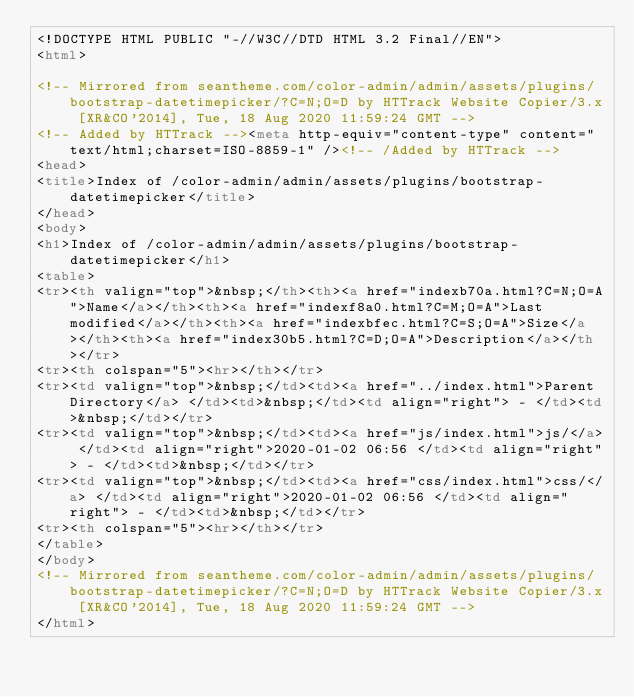<code> <loc_0><loc_0><loc_500><loc_500><_HTML_><!DOCTYPE HTML PUBLIC "-//W3C//DTD HTML 3.2 Final//EN">
<html>

<!-- Mirrored from seantheme.com/color-admin/admin/assets/plugins/bootstrap-datetimepicker/?C=N;O=D by HTTrack Website Copier/3.x [XR&CO'2014], Tue, 18 Aug 2020 11:59:24 GMT -->
<!-- Added by HTTrack --><meta http-equiv="content-type" content="text/html;charset=ISO-8859-1" /><!-- /Added by HTTrack -->
<head>
<title>Index of /color-admin/admin/assets/plugins/bootstrap-datetimepicker</title>
</head>
<body>
<h1>Index of /color-admin/admin/assets/plugins/bootstrap-datetimepicker</h1>
<table>
<tr><th valign="top">&nbsp;</th><th><a href="indexb70a.html?C=N;O=A">Name</a></th><th><a href="indexf8a0.html?C=M;O=A">Last modified</a></th><th><a href="indexbfec.html?C=S;O=A">Size</a></th><th><a href="index30b5.html?C=D;O=A">Description</a></th></tr>
<tr><th colspan="5"><hr></th></tr>
<tr><td valign="top">&nbsp;</td><td><a href="../index.html">Parent Directory</a> </td><td>&nbsp;</td><td align="right"> - </td><td>&nbsp;</td></tr>
<tr><td valign="top">&nbsp;</td><td><a href="js/index.html">js/</a> </td><td align="right">2020-01-02 06:56 </td><td align="right"> - </td><td>&nbsp;</td></tr>
<tr><td valign="top">&nbsp;</td><td><a href="css/index.html">css/</a> </td><td align="right">2020-01-02 06:56 </td><td align="right"> - </td><td>&nbsp;</td></tr>
<tr><th colspan="5"><hr></th></tr>
</table>
</body>
<!-- Mirrored from seantheme.com/color-admin/admin/assets/plugins/bootstrap-datetimepicker/?C=N;O=D by HTTrack Website Copier/3.x [XR&CO'2014], Tue, 18 Aug 2020 11:59:24 GMT -->
</html>
</code> 